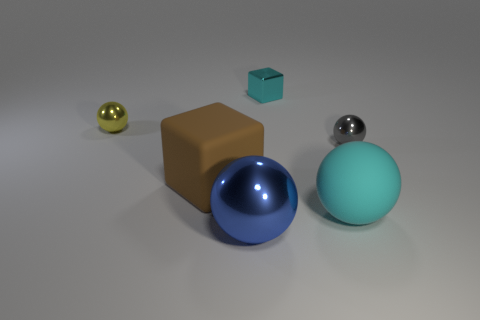Is the number of metal spheres that are left of the yellow metal object greater than the number of tiny matte blocks?
Offer a very short reply. No. What number of gray metal spheres are on the left side of the tiny metallic thing left of the cyan shiny cube?
Your response must be concise. 0. What is the shape of the small object that is in front of the shiny sphere that is behind the small shiny ball that is on the right side of the big metallic ball?
Your answer should be compact. Sphere. How big is the blue shiny ball?
Make the answer very short. Large. Is there a tiny cube made of the same material as the tiny yellow thing?
Offer a terse response. Yes. What is the size of the yellow object that is the same shape as the tiny gray object?
Your answer should be very brief. Small. Is the number of brown matte objects that are to the right of the blue shiny object the same as the number of big blue spheres?
Offer a terse response. No. There is a big rubber object to the left of the large blue metal thing; does it have the same shape as the tiny cyan metal object?
Your response must be concise. Yes. What is the shape of the big blue object?
Offer a very short reply. Sphere. What is the material of the big sphere behind the metal thing in front of the big rubber object that is to the right of the big brown object?
Your answer should be compact. Rubber. 